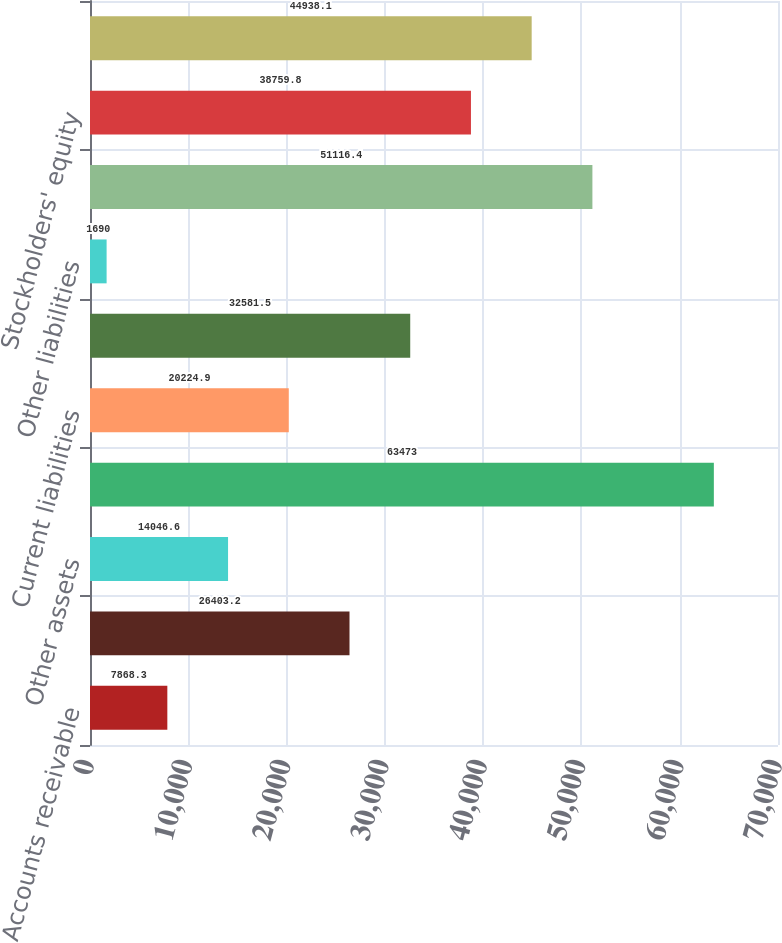<chart> <loc_0><loc_0><loc_500><loc_500><bar_chart><fcel>Accounts receivable<fcel>Total current assets<fcel>Other assets<fcel>Total assets<fcel>Current liabilities<fcel>Long-term debt less current<fcel>Other liabilities<fcel>Total liabilities<fcel>Stockholders' equity<fcel>Total equity<nl><fcel>7868.3<fcel>26403.2<fcel>14046.6<fcel>63473<fcel>20224.9<fcel>32581.5<fcel>1690<fcel>51116.4<fcel>38759.8<fcel>44938.1<nl></chart> 